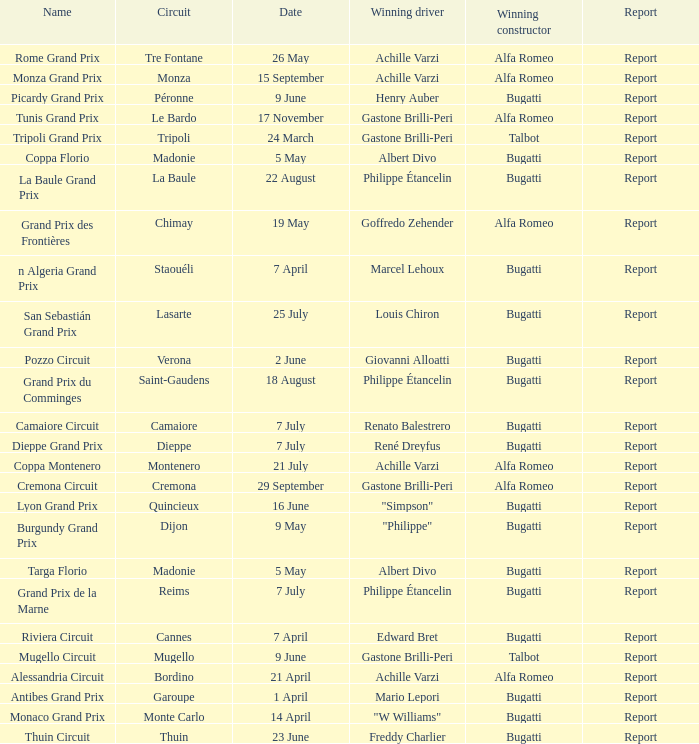What Circuit has a Winning constructor of bugatti, and a Winning driver of edward bret? Cannes. 